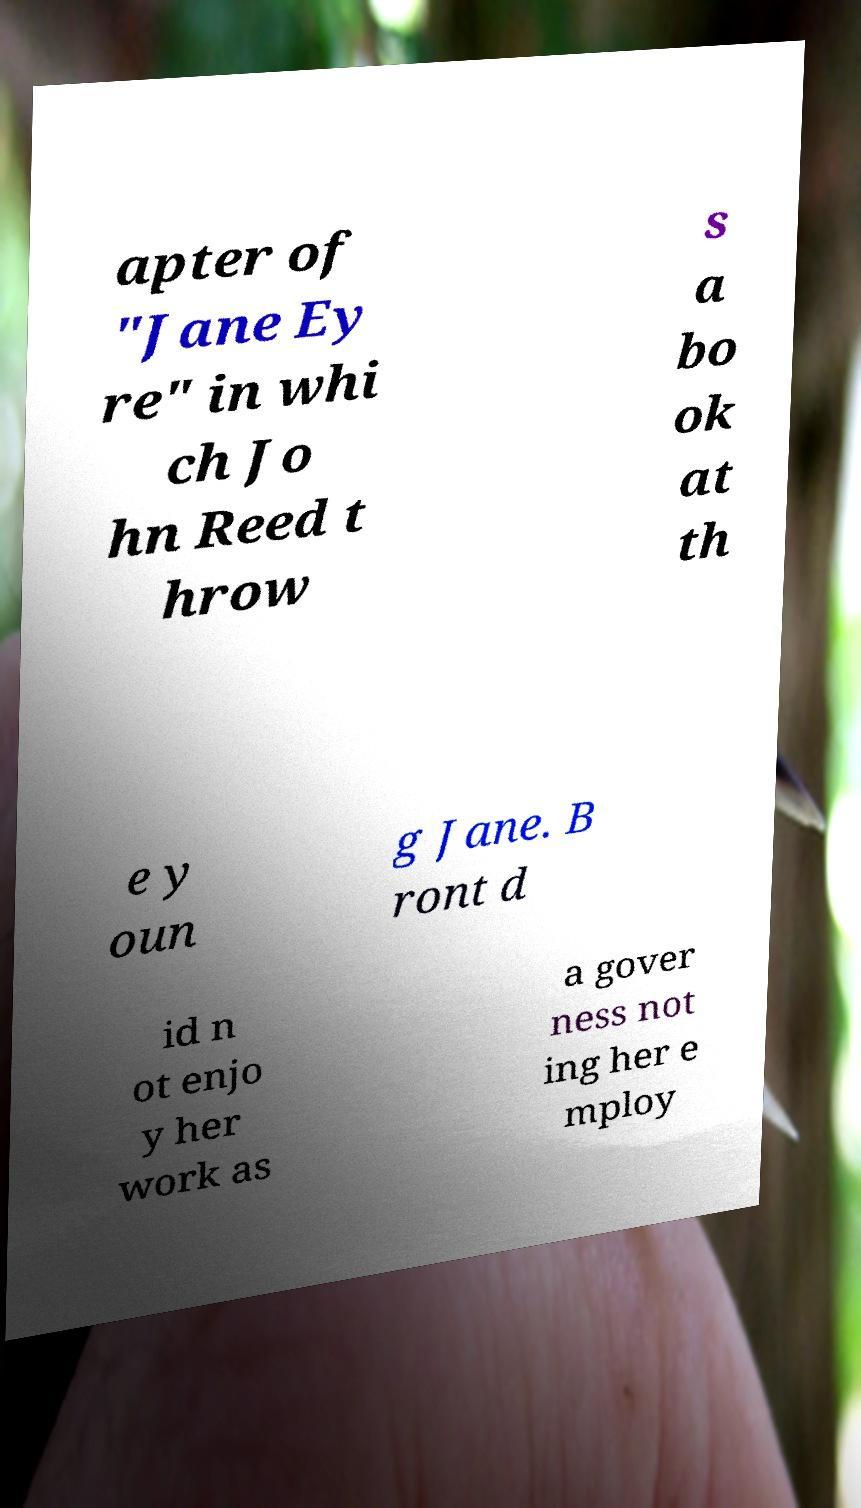Please read and relay the text visible in this image. What does it say? apter of "Jane Ey re" in whi ch Jo hn Reed t hrow s a bo ok at th e y oun g Jane. B ront d id n ot enjo y her work as a gover ness not ing her e mploy 